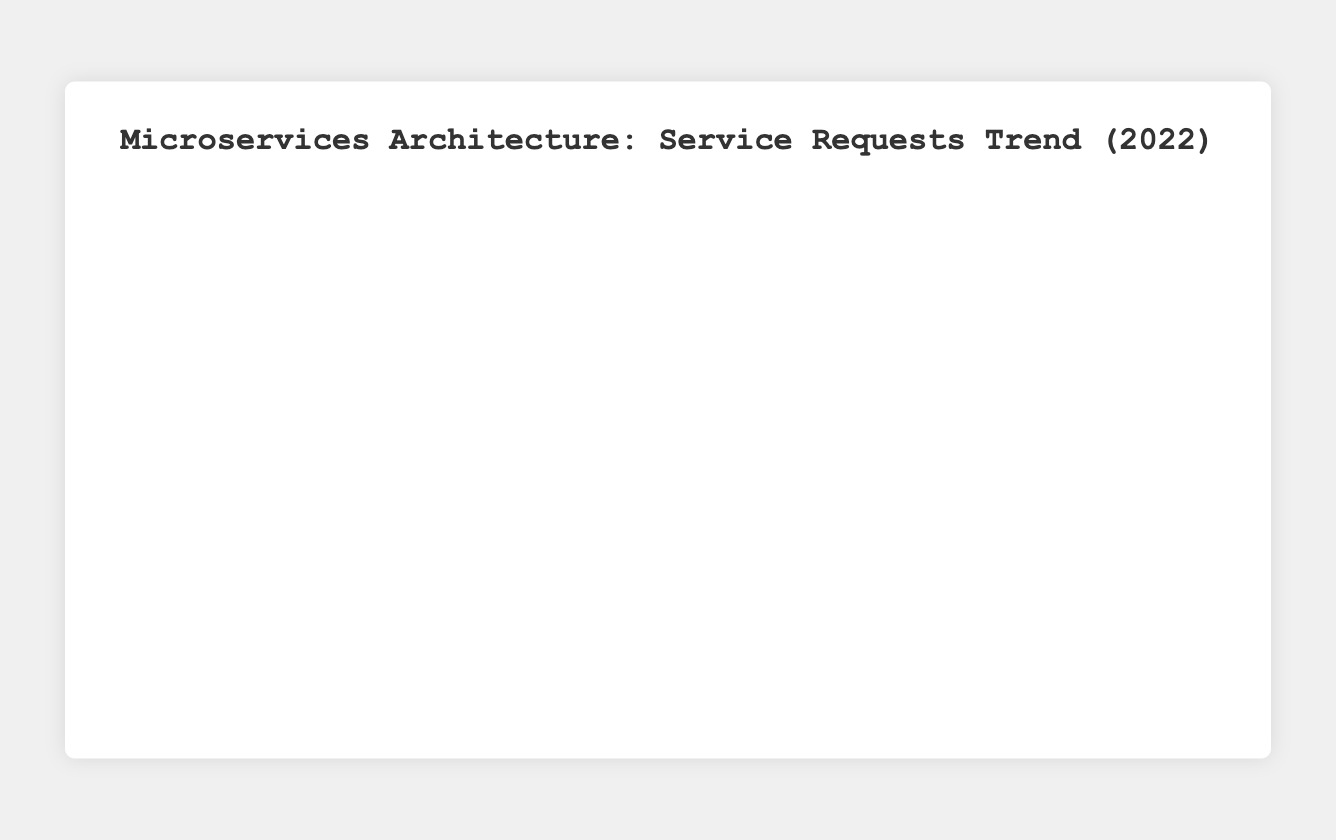Which service experienced the highest increase in the number of requests from January 1, 2022, to December 15, 2022? The increase can be found by subtracting the number of requests on January 1 from the number on December 15 for each service. For UserAuthentication: 710 - 350 = 360. For UserProfile: 670 - 400 = 270. For TransactionProcessing: 730 - 500 = 230. The highest increase is for UserAuthentication (360).
Answer: UserAuthentication Which service had the lowest number of requests on March 15, 2022? Compare the number of requests for each service on March 15, 2022. UserAuthentication: 410, UserProfile: 470, TransactionProcessing: 550. The minimum is for UserAuthentication (410).
Answer: UserAuthentication In which month did UserProfile see the largest month-to-month increase in the number of requests? Compare the increase from the first to the fifteenth of each month. January: 420 - 400 = 20, February: 445 - 430 = 15, March: 470 - 460 = 10, April: 490 - 480 = 10, May: 520 - 500 = 20, June: 540 - 530 = 10, July: 570 - 550 = 20, August: 590 - 580 = 10, September: 610 - 600 = 10, October: 630 - 620 = 10, November: 650 - 640 = 10, December: 670 - 660 = 10. The largest increase occurs in May, July, and November (20).
Answer: May or July or November What is the difference in the number of requests between UserAuthentication and UserProfile services on June 15, 2022? Compare the number of requests for UserAuthentication and UserProfile on June 15, 2022. UserAuthentication: 540, UserProfile: 540. The difference is 540 - 540 = 0.
Answer: 0 Which service had the most consistent (least variable) number of requests throughout the year? Visually scanning the trends, compare the variation in requests among the services. UserAuthentication shows a gradual and steady increase compared to the others. UserProfile and TransactionProcessing also show steady increase patterns but with more consistent trends.
Answer: UserProfile 